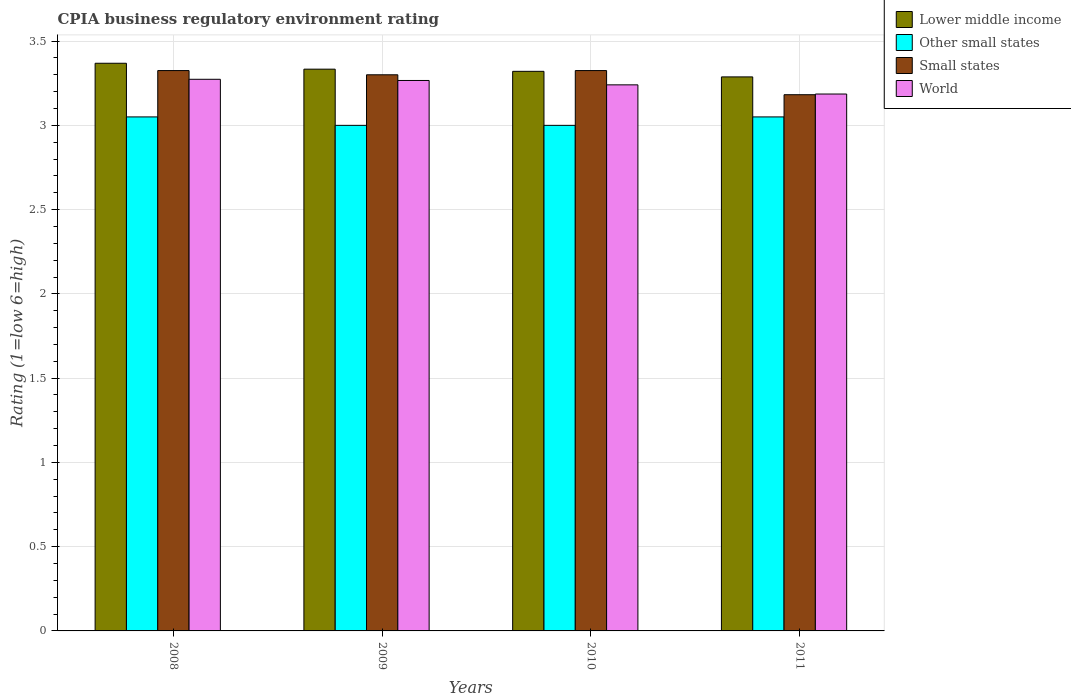How many groups of bars are there?
Provide a short and direct response. 4. Are the number of bars on each tick of the X-axis equal?
Your answer should be compact. Yes. How many bars are there on the 3rd tick from the left?
Your answer should be compact. 4. What is the label of the 1st group of bars from the left?
Give a very brief answer. 2008. In how many cases, is the number of bars for a given year not equal to the number of legend labels?
Your answer should be compact. 0. What is the CPIA rating in World in 2008?
Ensure brevity in your answer.  3.27. Across all years, what is the maximum CPIA rating in Lower middle income?
Ensure brevity in your answer.  3.37. Across all years, what is the minimum CPIA rating in Small states?
Keep it short and to the point. 3.18. In which year was the CPIA rating in World maximum?
Keep it short and to the point. 2008. In which year was the CPIA rating in Small states minimum?
Offer a terse response. 2011. What is the total CPIA rating in Other small states in the graph?
Offer a terse response. 12.1. What is the difference between the CPIA rating in World in 2009 and that in 2010?
Provide a succinct answer. 0.03. What is the difference between the CPIA rating in World in 2010 and the CPIA rating in Small states in 2009?
Offer a terse response. -0.06. What is the average CPIA rating in Lower middle income per year?
Keep it short and to the point. 3.33. In the year 2011, what is the difference between the CPIA rating in Lower middle income and CPIA rating in Other small states?
Ensure brevity in your answer.  0.24. In how many years, is the CPIA rating in Other small states greater than 2.6?
Make the answer very short. 4. What is the ratio of the CPIA rating in Small states in 2008 to that in 2011?
Give a very brief answer. 1.05. What is the difference between the highest and the second highest CPIA rating in Small states?
Provide a succinct answer. 0. What is the difference between the highest and the lowest CPIA rating in Other small states?
Keep it short and to the point. 0.05. In how many years, is the CPIA rating in World greater than the average CPIA rating in World taken over all years?
Offer a terse response. 2. Is the sum of the CPIA rating in Lower middle income in 2008 and 2010 greater than the maximum CPIA rating in World across all years?
Keep it short and to the point. Yes. Is it the case that in every year, the sum of the CPIA rating in Lower middle income and CPIA rating in World is greater than the CPIA rating in Other small states?
Your response must be concise. Yes. What is the difference between two consecutive major ticks on the Y-axis?
Your response must be concise. 0.5. Are the values on the major ticks of Y-axis written in scientific E-notation?
Your answer should be compact. No. Does the graph contain any zero values?
Provide a short and direct response. No. How many legend labels are there?
Your response must be concise. 4. What is the title of the graph?
Offer a very short reply. CPIA business regulatory environment rating. Does "El Salvador" appear as one of the legend labels in the graph?
Offer a terse response. No. What is the label or title of the Y-axis?
Offer a terse response. Rating (1=low 6=high). What is the Rating (1=low 6=high) in Lower middle income in 2008?
Your answer should be compact. 3.37. What is the Rating (1=low 6=high) in Other small states in 2008?
Offer a terse response. 3.05. What is the Rating (1=low 6=high) of Small states in 2008?
Provide a succinct answer. 3.33. What is the Rating (1=low 6=high) in World in 2008?
Offer a very short reply. 3.27. What is the Rating (1=low 6=high) of Lower middle income in 2009?
Offer a terse response. 3.33. What is the Rating (1=low 6=high) of World in 2009?
Provide a succinct answer. 3.27. What is the Rating (1=low 6=high) of Lower middle income in 2010?
Your answer should be very brief. 3.32. What is the Rating (1=low 6=high) in Small states in 2010?
Your answer should be very brief. 3.33. What is the Rating (1=low 6=high) of World in 2010?
Provide a short and direct response. 3.24. What is the Rating (1=low 6=high) of Lower middle income in 2011?
Your response must be concise. 3.29. What is the Rating (1=low 6=high) in Other small states in 2011?
Ensure brevity in your answer.  3.05. What is the Rating (1=low 6=high) in Small states in 2011?
Offer a terse response. 3.18. What is the Rating (1=low 6=high) of World in 2011?
Give a very brief answer. 3.19. Across all years, what is the maximum Rating (1=low 6=high) of Lower middle income?
Your response must be concise. 3.37. Across all years, what is the maximum Rating (1=low 6=high) of Other small states?
Your answer should be very brief. 3.05. Across all years, what is the maximum Rating (1=low 6=high) of Small states?
Make the answer very short. 3.33. Across all years, what is the maximum Rating (1=low 6=high) in World?
Provide a succinct answer. 3.27. Across all years, what is the minimum Rating (1=low 6=high) of Lower middle income?
Offer a very short reply. 3.29. Across all years, what is the minimum Rating (1=low 6=high) in Small states?
Offer a terse response. 3.18. Across all years, what is the minimum Rating (1=low 6=high) of World?
Ensure brevity in your answer.  3.19. What is the total Rating (1=low 6=high) of Lower middle income in the graph?
Provide a succinct answer. 13.31. What is the total Rating (1=low 6=high) in Small states in the graph?
Your response must be concise. 13.13. What is the total Rating (1=low 6=high) in World in the graph?
Your answer should be compact. 12.97. What is the difference between the Rating (1=low 6=high) in Lower middle income in 2008 and that in 2009?
Your response must be concise. 0.04. What is the difference between the Rating (1=low 6=high) of Small states in 2008 and that in 2009?
Your response must be concise. 0.03. What is the difference between the Rating (1=low 6=high) in World in 2008 and that in 2009?
Make the answer very short. 0.01. What is the difference between the Rating (1=low 6=high) of Lower middle income in 2008 and that in 2010?
Your answer should be compact. 0.05. What is the difference between the Rating (1=low 6=high) of Other small states in 2008 and that in 2010?
Provide a short and direct response. 0.05. What is the difference between the Rating (1=low 6=high) in Small states in 2008 and that in 2010?
Offer a very short reply. 0. What is the difference between the Rating (1=low 6=high) in World in 2008 and that in 2010?
Provide a succinct answer. 0.03. What is the difference between the Rating (1=low 6=high) in Lower middle income in 2008 and that in 2011?
Your response must be concise. 0.08. What is the difference between the Rating (1=low 6=high) in Small states in 2008 and that in 2011?
Your response must be concise. 0.14. What is the difference between the Rating (1=low 6=high) in World in 2008 and that in 2011?
Your answer should be compact. 0.09. What is the difference between the Rating (1=low 6=high) of Lower middle income in 2009 and that in 2010?
Provide a short and direct response. 0.01. What is the difference between the Rating (1=low 6=high) in Other small states in 2009 and that in 2010?
Give a very brief answer. 0. What is the difference between the Rating (1=low 6=high) in Small states in 2009 and that in 2010?
Keep it short and to the point. -0.03. What is the difference between the Rating (1=low 6=high) in World in 2009 and that in 2010?
Provide a short and direct response. 0.03. What is the difference between the Rating (1=low 6=high) of Lower middle income in 2009 and that in 2011?
Keep it short and to the point. 0.05. What is the difference between the Rating (1=low 6=high) of Small states in 2009 and that in 2011?
Ensure brevity in your answer.  0.12. What is the difference between the Rating (1=low 6=high) in World in 2009 and that in 2011?
Ensure brevity in your answer.  0.08. What is the difference between the Rating (1=low 6=high) of Lower middle income in 2010 and that in 2011?
Offer a very short reply. 0.03. What is the difference between the Rating (1=low 6=high) of Small states in 2010 and that in 2011?
Your response must be concise. 0.14. What is the difference between the Rating (1=low 6=high) of World in 2010 and that in 2011?
Your answer should be compact. 0.05. What is the difference between the Rating (1=low 6=high) in Lower middle income in 2008 and the Rating (1=low 6=high) in Other small states in 2009?
Ensure brevity in your answer.  0.37. What is the difference between the Rating (1=low 6=high) in Lower middle income in 2008 and the Rating (1=low 6=high) in Small states in 2009?
Keep it short and to the point. 0.07. What is the difference between the Rating (1=low 6=high) in Lower middle income in 2008 and the Rating (1=low 6=high) in World in 2009?
Ensure brevity in your answer.  0.1. What is the difference between the Rating (1=low 6=high) of Other small states in 2008 and the Rating (1=low 6=high) of Small states in 2009?
Make the answer very short. -0.25. What is the difference between the Rating (1=low 6=high) in Other small states in 2008 and the Rating (1=low 6=high) in World in 2009?
Offer a terse response. -0.22. What is the difference between the Rating (1=low 6=high) in Small states in 2008 and the Rating (1=low 6=high) in World in 2009?
Offer a very short reply. 0.06. What is the difference between the Rating (1=low 6=high) in Lower middle income in 2008 and the Rating (1=low 6=high) in Other small states in 2010?
Your answer should be very brief. 0.37. What is the difference between the Rating (1=low 6=high) of Lower middle income in 2008 and the Rating (1=low 6=high) of Small states in 2010?
Keep it short and to the point. 0.04. What is the difference between the Rating (1=low 6=high) of Lower middle income in 2008 and the Rating (1=low 6=high) of World in 2010?
Give a very brief answer. 0.13. What is the difference between the Rating (1=low 6=high) in Other small states in 2008 and the Rating (1=low 6=high) in Small states in 2010?
Give a very brief answer. -0.28. What is the difference between the Rating (1=low 6=high) of Other small states in 2008 and the Rating (1=low 6=high) of World in 2010?
Offer a very short reply. -0.19. What is the difference between the Rating (1=low 6=high) of Small states in 2008 and the Rating (1=low 6=high) of World in 2010?
Make the answer very short. 0.08. What is the difference between the Rating (1=low 6=high) in Lower middle income in 2008 and the Rating (1=low 6=high) in Other small states in 2011?
Provide a succinct answer. 0.32. What is the difference between the Rating (1=low 6=high) in Lower middle income in 2008 and the Rating (1=low 6=high) in Small states in 2011?
Offer a terse response. 0.19. What is the difference between the Rating (1=low 6=high) in Lower middle income in 2008 and the Rating (1=low 6=high) in World in 2011?
Provide a succinct answer. 0.18. What is the difference between the Rating (1=low 6=high) in Other small states in 2008 and the Rating (1=low 6=high) in Small states in 2011?
Keep it short and to the point. -0.13. What is the difference between the Rating (1=low 6=high) in Other small states in 2008 and the Rating (1=low 6=high) in World in 2011?
Your answer should be compact. -0.14. What is the difference between the Rating (1=low 6=high) of Small states in 2008 and the Rating (1=low 6=high) of World in 2011?
Offer a very short reply. 0.14. What is the difference between the Rating (1=low 6=high) in Lower middle income in 2009 and the Rating (1=low 6=high) in Small states in 2010?
Ensure brevity in your answer.  0.01. What is the difference between the Rating (1=low 6=high) of Lower middle income in 2009 and the Rating (1=low 6=high) of World in 2010?
Your answer should be compact. 0.09. What is the difference between the Rating (1=low 6=high) in Other small states in 2009 and the Rating (1=low 6=high) in Small states in 2010?
Offer a terse response. -0.33. What is the difference between the Rating (1=low 6=high) of Other small states in 2009 and the Rating (1=low 6=high) of World in 2010?
Your answer should be very brief. -0.24. What is the difference between the Rating (1=low 6=high) in Small states in 2009 and the Rating (1=low 6=high) in World in 2010?
Your answer should be compact. 0.06. What is the difference between the Rating (1=low 6=high) in Lower middle income in 2009 and the Rating (1=low 6=high) in Other small states in 2011?
Your response must be concise. 0.28. What is the difference between the Rating (1=low 6=high) in Lower middle income in 2009 and the Rating (1=low 6=high) in Small states in 2011?
Offer a terse response. 0.15. What is the difference between the Rating (1=low 6=high) of Lower middle income in 2009 and the Rating (1=low 6=high) of World in 2011?
Your answer should be compact. 0.15. What is the difference between the Rating (1=low 6=high) of Other small states in 2009 and the Rating (1=low 6=high) of Small states in 2011?
Provide a succinct answer. -0.18. What is the difference between the Rating (1=low 6=high) of Other small states in 2009 and the Rating (1=low 6=high) of World in 2011?
Your response must be concise. -0.19. What is the difference between the Rating (1=low 6=high) in Small states in 2009 and the Rating (1=low 6=high) in World in 2011?
Make the answer very short. 0.11. What is the difference between the Rating (1=low 6=high) in Lower middle income in 2010 and the Rating (1=low 6=high) in Other small states in 2011?
Offer a terse response. 0.27. What is the difference between the Rating (1=low 6=high) in Lower middle income in 2010 and the Rating (1=low 6=high) in Small states in 2011?
Offer a terse response. 0.14. What is the difference between the Rating (1=low 6=high) of Lower middle income in 2010 and the Rating (1=low 6=high) of World in 2011?
Keep it short and to the point. 0.13. What is the difference between the Rating (1=low 6=high) of Other small states in 2010 and the Rating (1=low 6=high) of Small states in 2011?
Provide a succinct answer. -0.18. What is the difference between the Rating (1=low 6=high) of Other small states in 2010 and the Rating (1=low 6=high) of World in 2011?
Offer a very short reply. -0.19. What is the difference between the Rating (1=low 6=high) in Small states in 2010 and the Rating (1=low 6=high) in World in 2011?
Your response must be concise. 0.14. What is the average Rating (1=low 6=high) of Lower middle income per year?
Keep it short and to the point. 3.33. What is the average Rating (1=low 6=high) of Other small states per year?
Provide a succinct answer. 3.02. What is the average Rating (1=low 6=high) of Small states per year?
Your answer should be compact. 3.28. What is the average Rating (1=low 6=high) in World per year?
Your answer should be compact. 3.24. In the year 2008, what is the difference between the Rating (1=low 6=high) in Lower middle income and Rating (1=low 6=high) in Other small states?
Keep it short and to the point. 0.32. In the year 2008, what is the difference between the Rating (1=low 6=high) in Lower middle income and Rating (1=low 6=high) in Small states?
Ensure brevity in your answer.  0.04. In the year 2008, what is the difference between the Rating (1=low 6=high) in Lower middle income and Rating (1=low 6=high) in World?
Your response must be concise. 0.1. In the year 2008, what is the difference between the Rating (1=low 6=high) of Other small states and Rating (1=low 6=high) of Small states?
Your answer should be compact. -0.28. In the year 2008, what is the difference between the Rating (1=low 6=high) in Other small states and Rating (1=low 6=high) in World?
Keep it short and to the point. -0.22. In the year 2008, what is the difference between the Rating (1=low 6=high) in Small states and Rating (1=low 6=high) in World?
Ensure brevity in your answer.  0.05. In the year 2009, what is the difference between the Rating (1=low 6=high) in Lower middle income and Rating (1=low 6=high) in World?
Ensure brevity in your answer.  0.07. In the year 2009, what is the difference between the Rating (1=low 6=high) in Other small states and Rating (1=low 6=high) in Small states?
Offer a very short reply. -0.3. In the year 2009, what is the difference between the Rating (1=low 6=high) in Other small states and Rating (1=low 6=high) in World?
Provide a succinct answer. -0.27. In the year 2009, what is the difference between the Rating (1=low 6=high) in Small states and Rating (1=low 6=high) in World?
Keep it short and to the point. 0.03. In the year 2010, what is the difference between the Rating (1=low 6=high) in Lower middle income and Rating (1=low 6=high) in Other small states?
Give a very brief answer. 0.32. In the year 2010, what is the difference between the Rating (1=low 6=high) in Lower middle income and Rating (1=low 6=high) in Small states?
Your answer should be very brief. -0. In the year 2010, what is the difference between the Rating (1=low 6=high) in Lower middle income and Rating (1=low 6=high) in World?
Offer a very short reply. 0.08. In the year 2010, what is the difference between the Rating (1=low 6=high) of Other small states and Rating (1=low 6=high) of Small states?
Provide a short and direct response. -0.33. In the year 2010, what is the difference between the Rating (1=low 6=high) in Other small states and Rating (1=low 6=high) in World?
Your answer should be compact. -0.24. In the year 2010, what is the difference between the Rating (1=low 6=high) in Small states and Rating (1=low 6=high) in World?
Give a very brief answer. 0.08. In the year 2011, what is the difference between the Rating (1=low 6=high) of Lower middle income and Rating (1=low 6=high) of Other small states?
Keep it short and to the point. 0.24. In the year 2011, what is the difference between the Rating (1=low 6=high) of Lower middle income and Rating (1=low 6=high) of Small states?
Give a very brief answer. 0.11. In the year 2011, what is the difference between the Rating (1=low 6=high) in Lower middle income and Rating (1=low 6=high) in World?
Offer a terse response. 0.1. In the year 2011, what is the difference between the Rating (1=low 6=high) in Other small states and Rating (1=low 6=high) in Small states?
Offer a terse response. -0.13. In the year 2011, what is the difference between the Rating (1=low 6=high) in Other small states and Rating (1=low 6=high) in World?
Ensure brevity in your answer.  -0.14. In the year 2011, what is the difference between the Rating (1=low 6=high) of Small states and Rating (1=low 6=high) of World?
Ensure brevity in your answer.  -0. What is the ratio of the Rating (1=low 6=high) in Lower middle income in 2008 to that in 2009?
Ensure brevity in your answer.  1.01. What is the ratio of the Rating (1=low 6=high) of Other small states in 2008 to that in 2009?
Your answer should be compact. 1.02. What is the ratio of the Rating (1=low 6=high) of Small states in 2008 to that in 2009?
Offer a terse response. 1.01. What is the ratio of the Rating (1=low 6=high) of World in 2008 to that in 2009?
Offer a terse response. 1. What is the ratio of the Rating (1=low 6=high) of Lower middle income in 2008 to that in 2010?
Keep it short and to the point. 1.01. What is the ratio of the Rating (1=low 6=high) in Other small states in 2008 to that in 2010?
Your answer should be compact. 1.02. What is the ratio of the Rating (1=low 6=high) in Small states in 2008 to that in 2010?
Ensure brevity in your answer.  1. What is the ratio of the Rating (1=low 6=high) of World in 2008 to that in 2010?
Provide a succinct answer. 1.01. What is the ratio of the Rating (1=low 6=high) in Lower middle income in 2008 to that in 2011?
Offer a terse response. 1.02. What is the ratio of the Rating (1=low 6=high) of Other small states in 2008 to that in 2011?
Your answer should be very brief. 1. What is the ratio of the Rating (1=low 6=high) of Small states in 2008 to that in 2011?
Make the answer very short. 1.04. What is the ratio of the Rating (1=low 6=high) of World in 2008 to that in 2011?
Your answer should be compact. 1.03. What is the ratio of the Rating (1=low 6=high) of Other small states in 2009 to that in 2010?
Make the answer very short. 1. What is the ratio of the Rating (1=low 6=high) of Small states in 2009 to that in 2010?
Make the answer very short. 0.99. What is the ratio of the Rating (1=low 6=high) of Lower middle income in 2009 to that in 2011?
Your answer should be compact. 1.01. What is the ratio of the Rating (1=low 6=high) in Other small states in 2009 to that in 2011?
Keep it short and to the point. 0.98. What is the ratio of the Rating (1=low 6=high) in Small states in 2009 to that in 2011?
Your answer should be compact. 1.04. What is the ratio of the Rating (1=low 6=high) of World in 2009 to that in 2011?
Make the answer very short. 1.03. What is the ratio of the Rating (1=low 6=high) of Other small states in 2010 to that in 2011?
Your response must be concise. 0.98. What is the ratio of the Rating (1=low 6=high) in Small states in 2010 to that in 2011?
Keep it short and to the point. 1.04. What is the ratio of the Rating (1=low 6=high) of World in 2010 to that in 2011?
Your answer should be compact. 1.02. What is the difference between the highest and the second highest Rating (1=low 6=high) of Lower middle income?
Give a very brief answer. 0.04. What is the difference between the highest and the second highest Rating (1=low 6=high) in Other small states?
Ensure brevity in your answer.  0. What is the difference between the highest and the second highest Rating (1=low 6=high) of Small states?
Provide a short and direct response. 0. What is the difference between the highest and the second highest Rating (1=low 6=high) of World?
Your answer should be very brief. 0.01. What is the difference between the highest and the lowest Rating (1=low 6=high) in Lower middle income?
Ensure brevity in your answer.  0.08. What is the difference between the highest and the lowest Rating (1=low 6=high) of Small states?
Ensure brevity in your answer.  0.14. What is the difference between the highest and the lowest Rating (1=low 6=high) in World?
Keep it short and to the point. 0.09. 